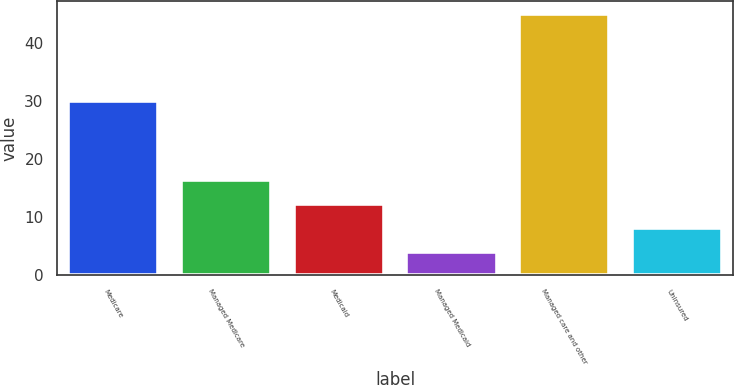<chart> <loc_0><loc_0><loc_500><loc_500><bar_chart><fcel>Medicare<fcel>Managed Medicare<fcel>Medicaid<fcel>Managed Medicaid<fcel>Managed care and other<fcel>Uninsured<nl><fcel>30<fcel>16.3<fcel>12.2<fcel>4<fcel>45<fcel>8.1<nl></chart> 